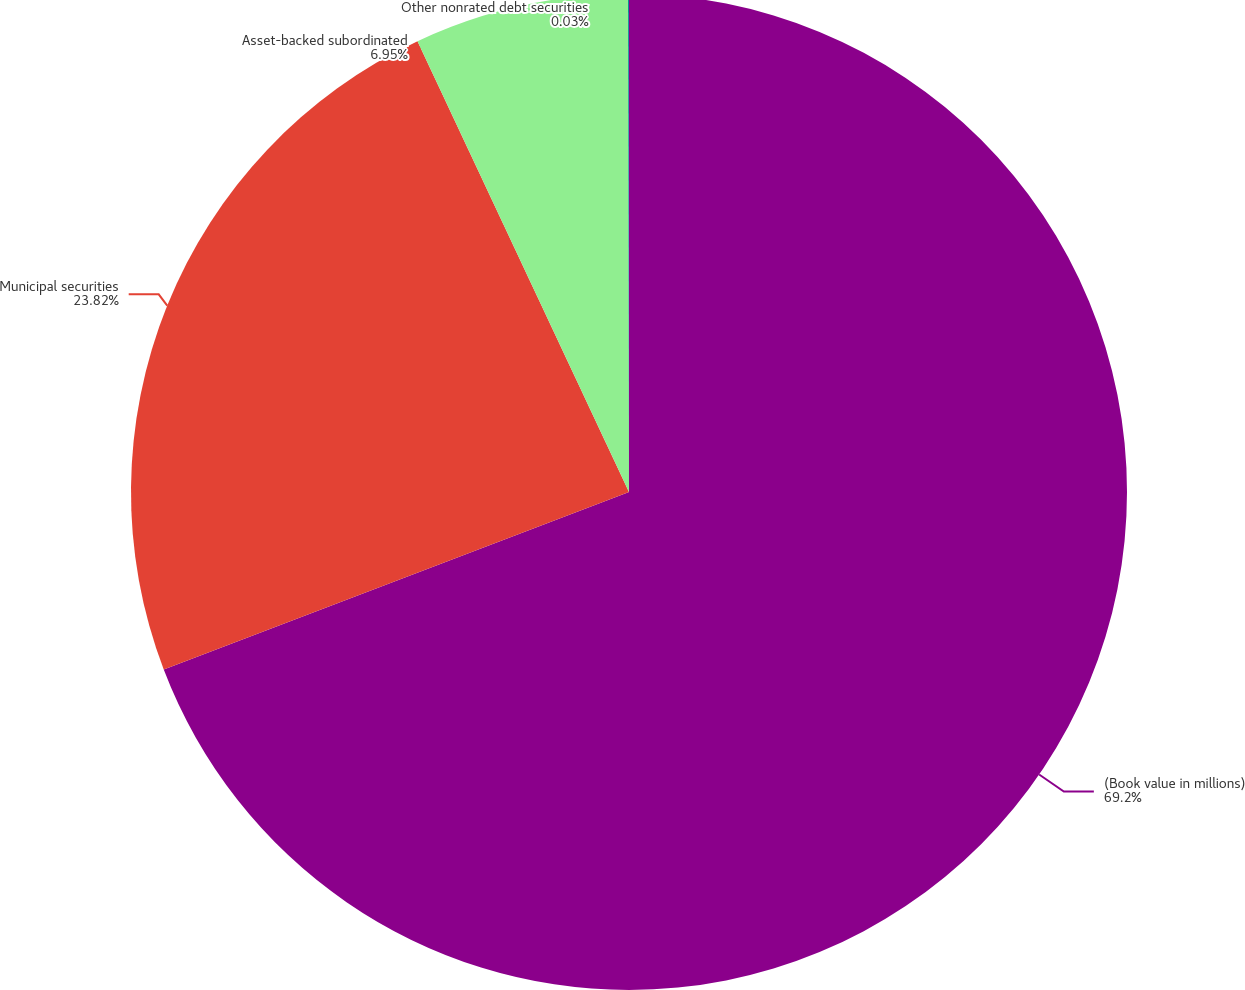<chart> <loc_0><loc_0><loc_500><loc_500><pie_chart><fcel>(Book value in millions)<fcel>Municipal securities<fcel>Asset-backed subordinated<fcel>Other nonrated debt securities<nl><fcel>69.19%<fcel>23.82%<fcel>6.95%<fcel>0.03%<nl></chart> 